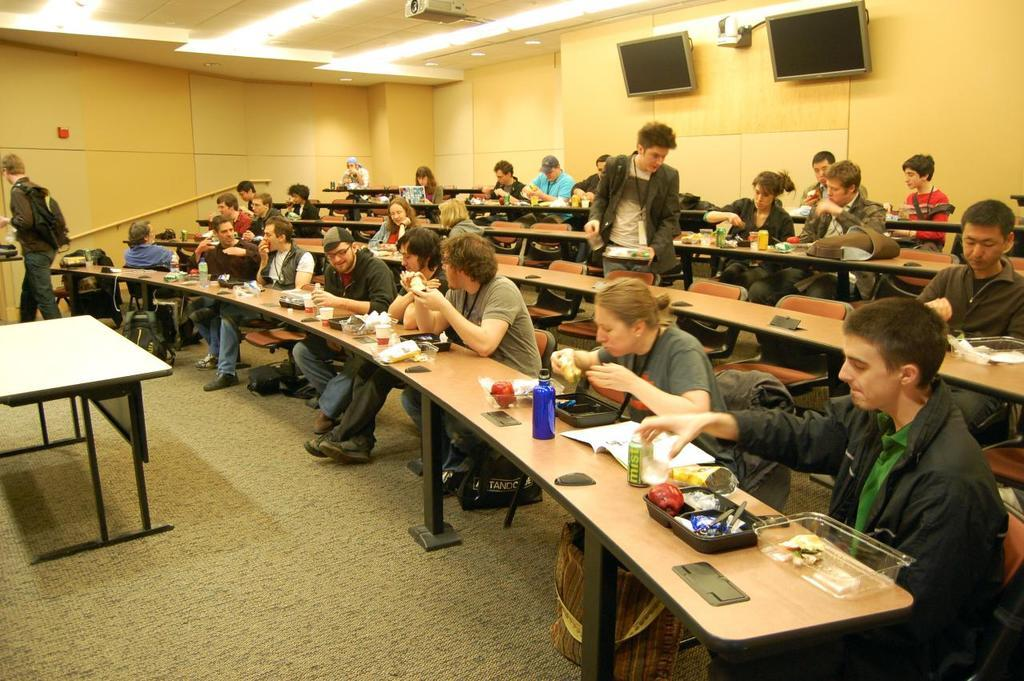How many people are sitting on the bench in the image? There are many people sitting on the bench in the image. What object can be seen in the image besides the people on the bench? There is a box in the image. What is inside the box? There is an apple in the box. What other object can be seen in the image? There is a can in the image. How many hands are visible in the image? There is no mention of hands in the provided facts, so we cannot determine how many hands are visible in the image. 